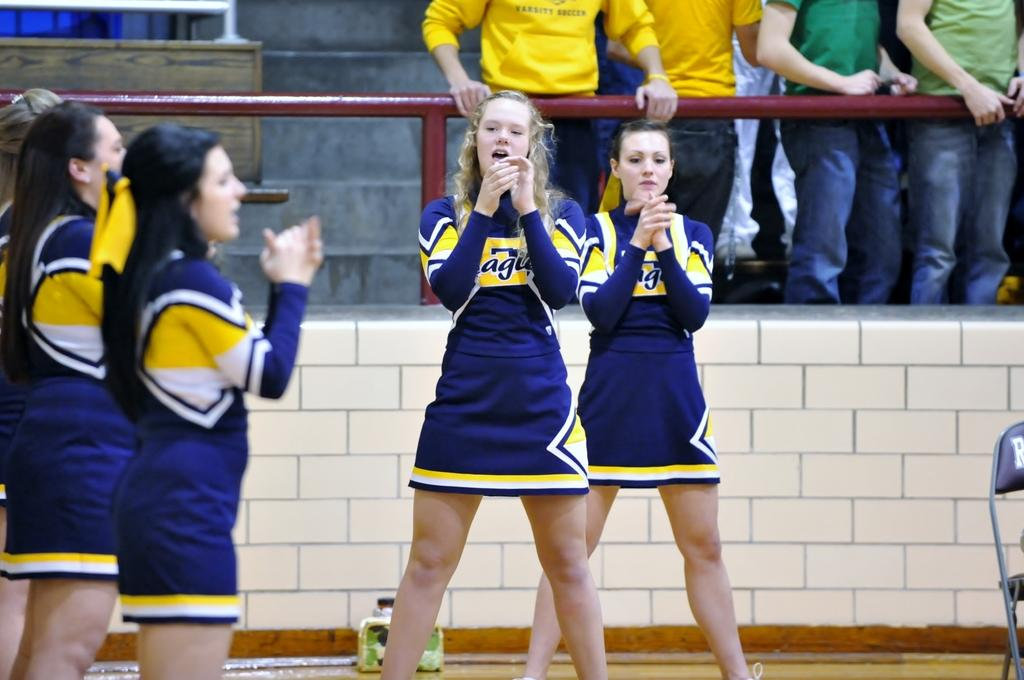Provide a one-sentence caption for the provided image. Cheerleaders wear a yellow and navy uniform with the letters agu on them. 